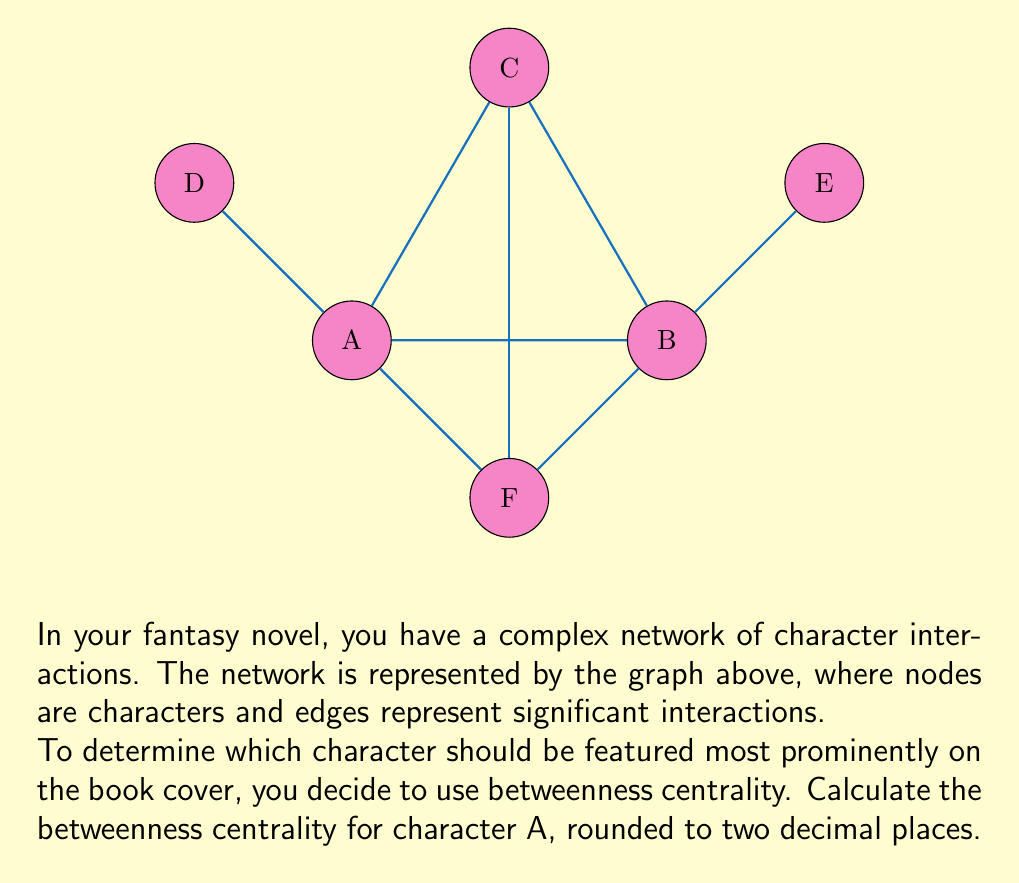Help me with this question. To calculate the betweenness centrality for character A, we need to follow these steps:

1) First, let's understand betweenness centrality. It's defined as:

   $$C_B(v) = \sum_{s \neq v \neq t} \frac{\sigma_{st}(v)}{\sigma_{st}}$$

   where $\sigma_{st}$ is the total number of shortest paths from node s to node t, and $\sigma_{st}(v)$ is the number of those paths that pass through v.

2) We need to consider all pairs of nodes (excluding A) and calculate how many shortest paths between them pass through A.

3) Let's list all pairs and their shortest paths:
   - B-C: B-A-C, B-F-C (2 paths, 1 through A)
   - B-D: B-A-D (1 path, 1 through A)
   - B-E: B-E (1 path, 0 through A)
   - B-F: B-F (1 path, 0 through A)
   - C-D: C-A-D (1 path, 1 through A)
   - C-E: C-A-B-E, C-F-B-E (2 paths, 1 through A)
   - C-F: C-F (1 path, 0 through A)
   - D-E: D-A-B-E (1 path, 1 through A)
   - D-F: D-A-F (1 path, 1 through A)
   - E-F: E-B-F (1 path, 0 through A)

4) Now, let's sum up the fractions:
   $$C_B(A) = \frac{1}{2} + 1 + 0 + 0 + 1 + \frac{1}{2} + 0 + 1 + 1 + 0 = 5$$

5) To normalize this value, we divide by the number of possible pairs excluding A:
   $$(n-1)(n-2)/2 = (5 * 4)/2 = 10$$

6) Therefore, the normalized betweenness centrality for A is:
   $$C_B'(A) = 5/10 = 0.5$$

Rounded to two decimal places, this remains 0.50.
Answer: 0.50 